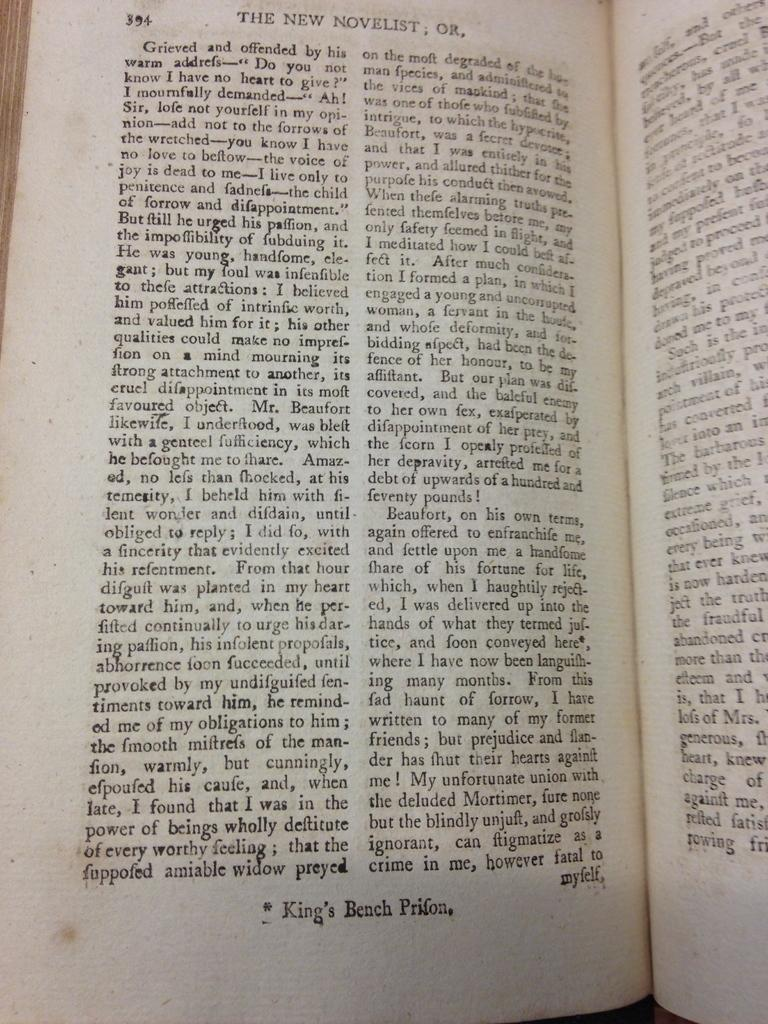<image>
Share a concise interpretation of the image provided. Page 394 of this book ends with the word myself. 